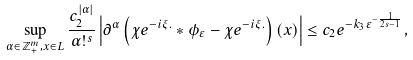Convert formula to latex. <formula><loc_0><loc_0><loc_500><loc_500>\sup _ { \alpha \in \mathbb { Z } _ { + } ^ { m } , x \in L } \frac { c _ { 2 } ^ { \left | \alpha \right | } } { \alpha ! ^ { s } } \left | \partial ^ { \alpha } \left ( \chi e ^ { - i \xi . } \ast \phi _ { \varepsilon } - \chi e ^ { - i \xi . } \right ) \left ( x \right ) \right | \leq c _ { 2 } e ^ { - k _ { 3 } \varepsilon ^ { - \frac { 1 } { 2 s - 1 } } } ,</formula> 